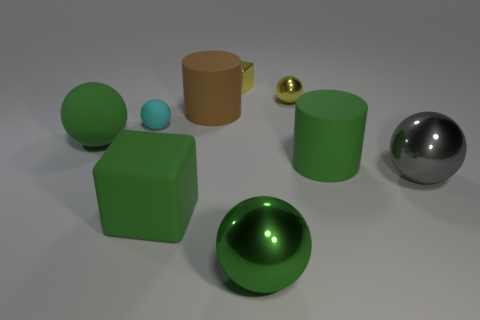What is the color of the small sphere on the right side of the matte block that is in front of the tiny rubber sphere? yellow 